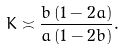Convert formula to latex. <formula><loc_0><loc_0><loc_500><loc_500>K \asymp \frac { b \, ( 1 - 2 a ) } { a \, ( 1 - 2 b ) } .</formula> 